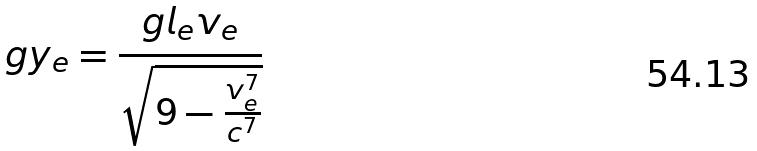Convert formula to latex. <formula><loc_0><loc_0><loc_500><loc_500>g y _ { e } = \frac { g l _ { e } v _ { e } } { \sqrt { 9 - \frac { v _ { e } ^ { 7 } } { c ^ { 7 } } } }</formula> 